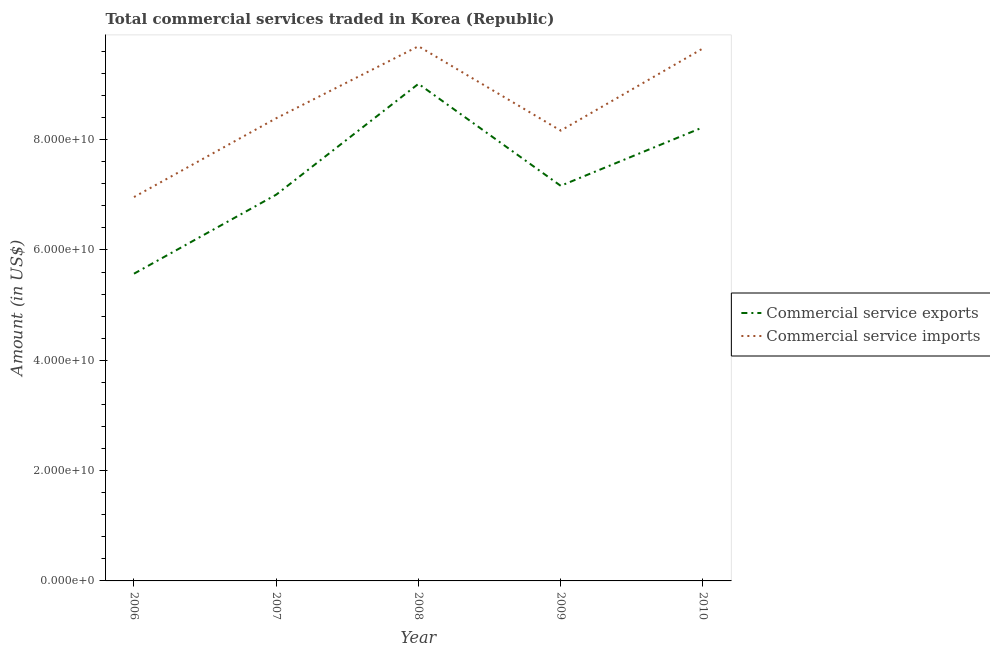Does the line corresponding to amount of commercial service imports intersect with the line corresponding to amount of commercial service exports?
Keep it short and to the point. No. Is the number of lines equal to the number of legend labels?
Keep it short and to the point. Yes. What is the amount of commercial service imports in 2008?
Keep it short and to the point. 9.69e+1. Across all years, what is the maximum amount of commercial service imports?
Make the answer very short. 9.69e+1. Across all years, what is the minimum amount of commercial service imports?
Offer a terse response. 6.96e+1. In which year was the amount of commercial service imports maximum?
Offer a terse response. 2008. In which year was the amount of commercial service exports minimum?
Make the answer very short. 2006. What is the total amount of commercial service exports in the graph?
Your answer should be very brief. 3.70e+11. What is the difference between the amount of commercial service exports in 2008 and that in 2010?
Provide a short and direct response. 7.88e+09. What is the difference between the amount of commercial service exports in 2006 and the amount of commercial service imports in 2009?
Make the answer very short. -2.59e+1. What is the average amount of commercial service exports per year?
Offer a terse response. 7.39e+1. In the year 2006, what is the difference between the amount of commercial service imports and amount of commercial service exports?
Your response must be concise. 1.39e+1. In how many years, is the amount of commercial service imports greater than 68000000000 US$?
Offer a very short reply. 5. What is the ratio of the amount of commercial service imports in 2007 to that in 2010?
Provide a succinct answer. 0.87. Is the amount of commercial service exports in 2007 less than that in 2008?
Your answer should be very brief. Yes. Is the difference between the amount of commercial service exports in 2007 and 2010 greater than the difference between the amount of commercial service imports in 2007 and 2010?
Your answer should be very brief. Yes. What is the difference between the highest and the second highest amount of commercial service imports?
Your answer should be compact. 3.94e+08. What is the difference between the highest and the lowest amount of commercial service exports?
Your answer should be very brief. 3.44e+1. Does the amount of commercial service imports monotonically increase over the years?
Give a very brief answer. No. Is the amount of commercial service imports strictly greater than the amount of commercial service exports over the years?
Provide a short and direct response. Yes. How many lines are there?
Your answer should be very brief. 2. How many years are there in the graph?
Give a very brief answer. 5. What is the difference between two consecutive major ticks on the Y-axis?
Ensure brevity in your answer.  2.00e+1. Does the graph contain grids?
Offer a terse response. No. Where does the legend appear in the graph?
Provide a short and direct response. Center right. How are the legend labels stacked?
Give a very brief answer. Vertical. What is the title of the graph?
Keep it short and to the point. Total commercial services traded in Korea (Republic). What is the label or title of the X-axis?
Offer a very short reply. Year. What is the label or title of the Y-axis?
Provide a short and direct response. Amount (in US$). What is the Amount (in US$) of Commercial service exports in 2006?
Give a very brief answer. 5.57e+1. What is the Amount (in US$) in Commercial service imports in 2006?
Ensure brevity in your answer.  6.96e+1. What is the Amount (in US$) of Commercial service exports in 2007?
Provide a short and direct response. 7.00e+1. What is the Amount (in US$) of Commercial service imports in 2007?
Your answer should be compact. 8.39e+1. What is the Amount (in US$) of Commercial service exports in 2008?
Offer a terse response. 9.01e+1. What is the Amount (in US$) of Commercial service imports in 2008?
Your answer should be very brief. 9.69e+1. What is the Amount (in US$) of Commercial service exports in 2009?
Keep it short and to the point. 7.16e+1. What is the Amount (in US$) of Commercial service imports in 2009?
Ensure brevity in your answer.  8.16e+1. What is the Amount (in US$) in Commercial service exports in 2010?
Give a very brief answer. 8.22e+1. What is the Amount (in US$) in Commercial service imports in 2010?
Provide a short and direct response. 9.65e+1. Across all years, what is the maximum Amount (in US$) of Commercial service exports?
Ensure brevity in your answer.  9.01e+1. Across all years, what is the maximum Amount (in US$) of Commercial service imports?
Your answer should be compact. 9.69e+1. Across all years, what is the minimum Amount (in US$) of Commercial service exports?
Provide a succinct answer. 5.57e+1. Across all years, what is the minimum Amount (in US$) of Commercial service imports?
Your answer should be compact. 6.96e+1. What is the total Amount (in US$) of Commercial service exports in the graph?
Provide a succinct answer. 3.70e+11. What is the total Amount (in US$) in Commercial service imports in the graph?
Offer a terse response. 4.29e+11. What is the difference between the Amount (in US$) of Commercial service exports in 2006 and that in 2007?
Give a very brief answer. -1.43e+1. What is the difference between the Amount (in US$) of Commercial service imports in 2006 and that in 2007?
Provide a short and direct response. -1.43e+1. What is the difference between the Amount (in US$) of Commercial service exports in 2006 and that in 2008?
Offer a terse response. -3.44e+1. What is the difference between the Amount (in US$) of Commercial service imports in 2006 and that in 2008?
Give a very brief answer. -2.73e+1. What is the difference between the Amount (in US$) in Commercial service exports in 2006 and that in 2009?
Provide a short and direct response. -1.59e+1. What is the difference between the Amount (in US$) in Commercial service imports in 2006 and that in 2009?
Ensure brevity in your answer.  -1.20e+1. What is the difference between the Amount (in US$) in Commercial service exports in 2006 and that in 2010?
Keep it short and to the point. -2.65e+1. What is the difference between the Amount (in US$) of Commercial service imports in 2006 and that in 2010?
Offer a terse response. -2.69e+1. What is the difference between the Amount (in US$) in Commercial service exports in 2007 and that in 2008?
Provide a short and direct response. -2.01e+1. What is the difference between the Amount (in US$) in Commercial service imports in 2007 and that in 2008?
Provide a short and direct response. -1.31e+1. What is the difference between the Amount (in US$) in Commercial service exports in 2007 and that in 2009?
Provide a short and direct response. -1.61e+09. What is the difference between the Amount (in US$) of Commercial service imports in 2007 and that in 2009?
Provide a succinct answer. 2.24e+09. What is the difference between the Amount (in US$) in Commercial service exports in 2007 and that in 2010?
Provide a short and direct response. -1.22e+1. What is the difference between the Amount (in US$) in Commercial service imports in 2007 and that in 2010?
Ensure brevity in your answer.  -1.27e+1. What is the difference between the Amount (in US$) of Commercial service exports in 2008 and that in 2009?
Ensure brevity in your answer.  1.85e+1. What is the difference between the Amount (in US$) of Commercial service imports in 2008 and that in 2009?
Your answer should be very brief. 1.53e+1. What is the difference between the Amount (in US$) of Commercial service exports in 2008 and that in 2010?
Provide a succinct answer. 7.88e+09. What is the difference between the Amount (in US$) in Commercial service imports in 2008 and that in 2010?
Your answer should be compact. 3.94e+08. What is the difference between the Amount (in US$) of Commercial service exports in 2009 and that in 2010?
Give a very brief answer. -1.06e+1. What is the difference between the Amount (in US$) of Commercial service imports in 2009 and that in 2010?
Ensure brevity in your answer.  -1.49e+1. What is the difference between the Amount (in US$) of Commercial service exports in 2006 and the Amount (in US$) of Commercial service imports in 2007?
Offer a terse response. -2.82e+1. What is the difference between the Amount (in US$) in Commercial service exports in 2006 and the Amount (in US$) in Commercial service imports in 2008?
Offer a terse response. -4.12e+1. What is the difference between the Amount (in US$) in Commercial service exports in 2006 and the Amount (in US$) in Commercial service imports in 2009?
Ensure brevity in your answer.  -2.59e+1. What is the difference between the Amount (in US$) in Commercial service exports in 2006 and the Amount (in US$) in Commercial service imports in 2010?
Give a very brief answer. -4.08e+1. What is the difference between the Amount (in US$) of Commercial service exports in 2007 and the Amount (in US$) of Commercial service imports in 2008?
Give a very brief answer. -2.69e+1. What is the difference between the Amount (in US$) in Commercial service exports in 2007 and the Amount (in US$) in Commercial service imports in 2009?
Ensure brevity in your answer.  -1.16e+1. What is the difference between the Amount (in US$) in Commercial service exports in 2007 and the Amount (in US$) in Commercial service imports in 2010?
Your answer should be compact. -2.65e+1. What is the difference between the Amount (in US$) of Commercial service exports in 2008 and the Amount (in US$) of Commercial service imports in 2009?
Your answer should be compact. 8.48e+09. What is the difference between the Amount (in US$) of Commercial service exports in 2008 and the Amount (in US$) of Commercial service imports in 2010?
Make the answer very short. -6.42e+09. What is the difference between the Amount (in US$) in Commercial service exports in 2009 and the Amount (in US$) in Commercial service imports in 2010?
Your answer should be very brief. -2.49e+1. What is the average Amount (in US$) in Commercial service exports per year?
Give a very brief answer. 7.39e+1. What is the average Amount (in US$) of Commercial service imports per year?
Make the answer very short. 8.57e+1. In the year 2006, what is the difference between the Amount (in US$) in Commercial service exports and Amount (in US$) in Commercial service imports?
Ensure brevity in your answer.  -1.39e+1. In the year 2007, what is the difference between the Amount (in US$) in Commercial service exports and Amount (in US$) in Commercial service imports?
Give a very brief answer. -1.39e+1. In the year 2008, what is the difference between the Amount (in US$) of Commercial service exports and Amount (in US$) of Commercial service imports?
Provide a short and direct response. -6.81e+09. In the year 2009, what is the difference between the Amount (in US$) of Commercial service exports and Amount (in US$) of Commercial service imports?
Provide a short and direct response. -1.00e+1. In the year 2010, what is the difference between the Amount (in US$) in Commercial service exports and Amount (in US$) in Commercial service imports?
Offer a very short reply. -1.43e+1. What is the ratio of the Amount (in US$) of Commercial service exports in 2006 to that in 2007?
Your answer should be compact. 0.8. What is the ratio of the Amount (in US$) in Commercial service imports in 2006 to that in 2007?
Give a very brief answer. 0.83. What is the ratio of the Amount (in US$) of Commercial service exports in 2006 to that in 2008?
Offer a very short reply. 0.62. What is the ratio of the Amount (in US$) of Commercial service imports in 2006 to that in 2008?
Your answer should be compact. 0.72. What is the ratio of the Amount (in US$) in Commercial service exports in 2006 to that in 2009?
Keep it short and to the point. 0.78. What is the ratio of the Amount (in US$) of Commercial service imports in 2006 to that in 2009?
Make the answer very short. 0.85. What is the ratio of the Amount (in US$) of Commercial service exports in 2006 to that in 2010?
Your answer should be very brief. 0.68. What is the ratio of the Amount (in US$) in Commercial service imports in 2006 to that in 2010?
Your response must be concise. 0.72. What is the ratio of the Amount (in US$) in Commercial service exports in 2007 to that in 2008?
Your answer should be very brief. 0.78. What is the ratio of the Amount (in US$) of Commercial service imports in 2007 to that in 2008?
Your response must be concise. 0.87. What is the ratio of the Amount (in US$) of Commercial service exports in 2007 to that in 2009?
Your answer should be very brief. 0.98. What is the ratio of the Amount (in US$) of Commercial service imports in 2007 to that in 2009?
Ensure brevity in your answer.  1.03. What is the ratio of the Amount (in US$) of Commercial service exports in 2007 to that in 2010?
Provide a short and direct response. 0.85. What is the ratio of the Amount (in US$) of Commercial service imports in 2007 to that in 2010?
Make the answer very short. 0.87. What is the ratio of the Amount (in US$) in Commercial service exports in 2008 to that in 2009?
Provide a short and direct response. 1.26. What is the ratio of the Amount (in US$) in Commercial service imports in 2008 to that in 2009?
Provide a short and direct response. 1.19. What is the ratio of the Amount (in US$) of Commercial service exports in 2008 to that in 2010?
Your answer should be very brief. 1.1. What is the ratio of the Amount (in US$) in Commercial service exports in 2009 to that in 2010?
Your answer should be very brief. 0.87. What is the ratio of the Amount (in US$) of Commercial service imports in 2009 to that in 2010?
Keep it short and to the point. 0.85. What is the difference between the highest and the second highest Amount (in US$) of Commercial service exports?
Give a very brief answer. 7.88e+09. What is the difference between the highest and the second highest Amount (in US$) of Commercial service imports?
Your answer should be very brief. 3.94e+08. What is the difference between the highest and the lowest Amount (in US$) in Commercial service exports?
Make the answer very short. 3.44e+1. What is the difference between the highest and the lowest Amount (in US$) of Commercial service imports?
Offer a very short reply. 2.73e+1. 